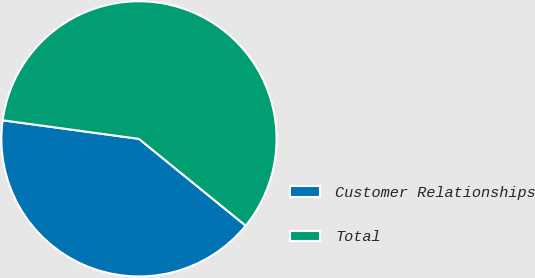Convert chart to OTSL. <chart><loc_0><loc_0><loc_500><loc_500><pie_chart><fcel>Customer Relationships<fcel>Total<nl><fcel>41.29%<fcel>58.71%<nl></chart> 